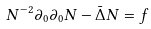<formula> <loc_0><loc_0><loc_500><loc_500>N ^ { - 2 } \partial _ { 0 } \partial _ { 0 } N - \bar { \Delta } N = f</formula> 